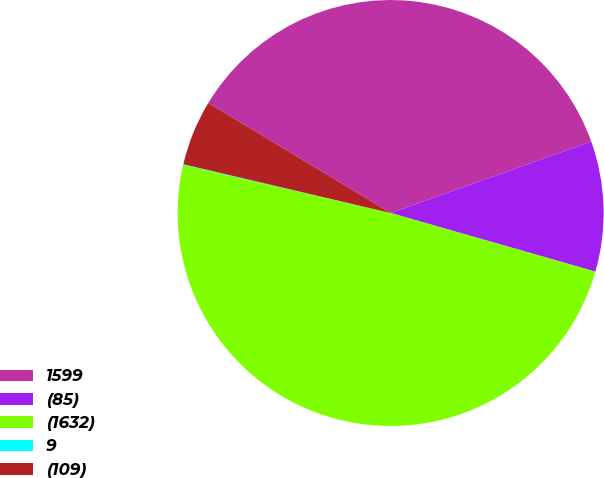Convert chart to OTSL. <chart><loc_0><loc_0><loc_500><loc_500><pie_chart><fcel>1599<fcel>(85)<fcel>(1632)<fcel>9<fcel>(109)<nl><fcel>35.92%<fcel>9.88%<fcel>49.19%<fcel>0.05%<fcel>4.96%<nl></chart> 